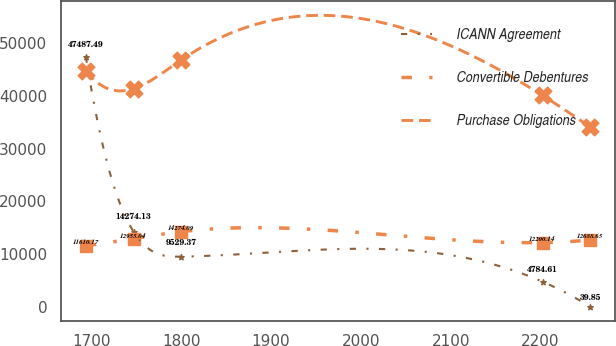<chart> <loc_0><loc_0><loc_500><loc_500><line_chart><ecel><fcel>ICANN Agreement<fcel>Convertible Debentures<fcel>Purchase Obligations<nl><fcel>1693.6<fcel>47487.5<fcel>11610.2<fcel>44791.5<nl><fcel>1746.73<fcel>14274.1<fcel>12955<fcel>41392.7<nl><fcel>1799.86<fcel>9529.37<fcel>14274.1<fcel>46848.1<nl><fcel>2202.28<fcel>4784.61<fcel>12200.1<fcel>40118.7<nl><fcel>2255.41<fcel>39.85<fcel>12688.6<fcel>34108.4<nl></chart> 